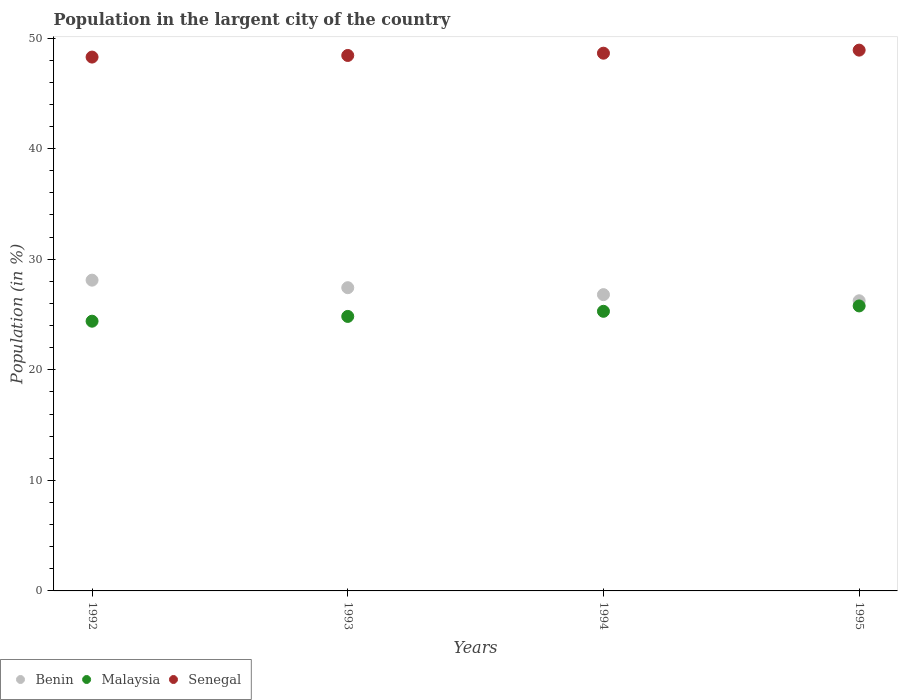How many different coloured dotlines are there?
Make the answer very short. 3. Is the number of dotlines equal to the number of legend labels?
Offer a very short reply. Yes. What is the percentage of population in the largent city in Malaysia in 1993?
Ensure brevity in your answer.  24.83. Across all years, what is the maximum percentage of population in the largent city in Malaysia?
Your answer should be compact. 25.78. Across all years, what is the minimum percentage of population in the largent city in Malaysia?
Keep it short and to the point. 24.39. What is the total percentage of population in the largent city in Benin in the graph?
Keep it short and to the point. 108.57. What is the difference between the percentage of population in the largent city in Malaysia in 1992 and that in 1995?
Give a very brief answer. -1.38. What is the difference between the percentage of population in the largent city in Malaysia in 1994 and the percentage of population in the largent city in Senegal in 1992?
Your answer should be compact. -22.99. What is the average percentage of population in the largent city in Senegal per year?
Offer a terse response. 48.56. In the year 1993, what is the difference between the percentage of population in the largent city in Senegal and percentage of population in the largent city in Malaysia?
Make the answer very short. 23.6. In how many years, is the percentage of population in the largent city in Malaysia greater than 48 %?
Offer a terse response. 0. What is the ratio of the percentage of population in the largent city in Malaysia in 1993 to that in 1994?
Offer a very short reply. 0.98. What is the difference between the highest and the second highest percentage of population in the largent city in Senegal?
Provide a succinct answer. 0.28. What is the difference between the highest and the lowest percentage of population in the largent city in Senegal?
Provide a short and direct response. 0.63. In how many years, is the percentage of population in the largent city in Malaysia greater than the average percentage of population in the largent city in Malaysia taken over all years?
Offer a terse response. 2. Is the sum of the percentage of population in the largent city in Malaysia in 1992 and 1994 greater than the maximum percentage of population in the largent city in Senegal across all years?
Ensure brevity in your answer.  Yes. Is it the case that in every year, the sum of the percentage of population in the largent city in Benin and percentage of population in the largent city in Malaysia  is greater than the percentage of population in the largent city in Senegal?
Ensure brevity in your answer.  Yes. Does the percentage of population in the largent city in Benin monotonically increase over the years?
Ensure brevity in your answer.  No. How many years are there in the graph?
Your answer should be very brief. 4. How many legend labels are there?
Ensure brevity in your answer.  3. How are the legend labels stacked?
Your response must be concise. Horizontal. What is the title of the graph?
Your response must be concise. Population in the largent city of the country. Does "Low & middle income" appear as one of the legend labels in the graph?
Your response must be concise. No. What is the Population (in %) in Benin in 1992?
Offer a terse response. 28.11. What is the Population (in %) of Malaysia in 1992?
Keep it short and to the point. 24.39. What is the Population (in %) in Senegal in 1992?
Your response must be concise. 48.28. What is the Population (in %) in Benin in 1993?
Provide a succinct answer. 27.43. What is the Population (in %) in Malaysia in 1993?
Offer a very short reply. 24.83. What is the Population (in %) in Senegal in 1993?
Your answer should be very brief. 48.43. What is the Population (in %) of Benin in 1994?
Provide a succinct answer. 26.8. What is the Population (in %) of Malaysia in 1994?
Ensure brevity in your answer.  25.29. What is the Population (in %) of Senegal in 1994?
Your answer should be very brief. 48.63. What is the Population (in %) in Benin in 1995?
Offer a very short reply. 26.24. What is the Population (in %) of Malaysia in 1995?
Give a very brief answer. 25.78. What is the Population (in %) in Senegal in 1995?
Your response must be concise. 48.91. Across all years, what is the maximum Population (in %) of Benin?
Provide a short and direct response. 28.11. Across all years, what is the maximum Population (in %) of Malaysia?
Provide a succinct answer. 25.78. Across all years, what is the maximum Population (in %) of Senegal?
Keep it short and to the point. 48.91. Across all years, what is the minimum Population (in %) in Benin?
Make the answer very short. 26.24. Across all years, what is the minimum Population (in %) of Malaysia?
Give a very brief answer. 24.39. Across all years, what is the minimum Population (in %) in Senegal?
Give a very brief answer. 48.28. What is the total Population (in %) of Benin in the graph?
Ensure brevity in your answer.  108.57. What is the total Population (in %) of Malaysia in the graph?
Your answer should be compact. 100.29. What is the total Population (in %) in Senegal in the graph?
Your answer should be very brief. 194.26. What is the difference between the Population (in %) in Benin in 1992 and that in 1993?
Your answer should be very brief. 0.68. What is the difference between the Population (in %) in Malaysia in 1992 and that in 1993?
Give a very brief answer. -0.43. What is the difference between the Population (in %) of Senegal in 1992 and that in 1993?
Ensure brevity in your answer.  -0.15. What is the difference between the Population (in %) of Benin in 1992 and that in 1994?
Keep it short and to the point. 1.31. What is the difference between the Population (in %) of Malaysia in 1992 and that in 1994?
Offer a very short reply. -0.89. What is the difference between the Population (in %) in Senegal in 1992 and that in 1994?
Provide a succinct answer. -0.35. What is the difference between the Population (in %) of Benin in 1992 and that in 1995?
Keep it short and to the point. 1.86. What is the difference between the Population (in %) of Malaysia in 1992 and that in 1995?
Ensure brevity in your answer.  -1.38. What is the difference between the Population (in %) in Senegal in 1992 and that in 1995?
Provide a short and direct response. -0.63. What is the difference between the Population (in %) in Benin in 1993 and that in 1994?
Your answer should be compact. 0.63. What is the difference between the Population (in %) of Malaysia in 1993 and that in 1994?
Provide a succinct answer. -0.46. What is the difference between the Population (in %) of Senegal in 1993 and that in 1994?
Offer a terse response. -0.21. What is the difference between the Population (in %) of Benin in 1993 and that in 1995?
Offer a very short reply. 1.18. What is the difference between the Population (in %) in Malaysia in 1993 and that in 1995?
Your answer should be compact. -0.95. What is the difference between the Population (in %) of Senegal in 1993 and that in 1995?
Your answer should be compact. -0.48. What is the difference between the Population (in %) of Benin in 1994 and that in 1995?
Give a very brief answer. 0.56. What is the difference between the Population (in %) in Malaysia in 1994 and that in 1995?
Your answer should be compact. -0.49. What is the difference between the Population (in %) of Senegal in 1994 and that in 1995?
Your answer should be very brief. -0.28. What is the difference between the Population (in %) in Benin in 1992 and the Population (in %) in Malaysia in 1993?
Give a very brief answer. 3.28. What is the difference between the Population (in %) in Benin in 1992 and the Population (in %) in Senegal in 1993?
Keep it short and to the point. -20.32. What is the difference between the Population (in %) of Malaysia in 1992 and the Population (in %) of Senegal in 1993?
Your response must be concise. -24.03. What is the difference between the Population (in %) of Benin in 1992 and the Population (in %) of Malaysia in 1994?
Your answer should be compact. 2.82. What is the difference between the Population (in %) of Benin in 1992 and the Population (in %) of Senegal in 1994?
Offer a terse response. -20.53. What is the difference between the Population (in %) in Malaysia in 1992 and the Population (in %) in Senegal in 1994?
Make the answer very short. -24.24. What is the difference between the Population (in %) in Benin in 1992 and the Population (in %) in Malaysia in 1995?
Provide a succinct answer. 2.33. What is the difference between the Population (in %) in Benin in 1992 and the Population (in %) in Senegal in 1995?
Your response must be concise. -20.8. What is the difference between the Population (in %) of Malaysia in 1992 and the Population (in %) of Senegal in 1995?
Provide a succinct answer. -24.52. What is the difference between the Population (in %) in Benin in 1993 and the Population (in %) in Malaysia in 1994?
Offer a terse response. 2.14. What is the difference between the Population (in %) of Benin in 1993 and the Population (in %) of Senegal in 1994?
Make the answer very short. -21.21. What is the difference between the Population (in %) of Malaysia in 1993 and the Population (in %) of Senegal in 1994?
Offer a very short reply. -23.81. What is the difference between the Population (in %) in Benin in 1993 and the Population (in %) in Malaysia in 1995?
Offer a very short reply. 1.65. What is the difference between the Population (in %) of Benin in 1993 and the Population (in %) of Senegal in 1995?
Make the answer very short. -21.49. What is the difference between the Population (in %) of Malaysia in 1993 and the Population (in %) of Senegal in 1995?
Ensure brevity in your answer.  -24.08. What is the difference between the Population (in %) of Benin in 1994 and the Population (in %) of Malaysia in 1995?
Your response must be concise. 1.02. What is the difference between the Population (in %) of Benin in 1994 and the Population (in %) of Senegal in 1995?
Offer a very short reply. -22.11. What is the difference between the Population (in %) in Malaysia in 1994 and the Population (in %) in Senegal in 1995?
Offer a very short reply. -23.62. What is the average Population (in %) of Benin per year?
Your answer should be compact. 27.14. What is the average Population (in %) in Malaysia per year?
Ensure brevity in your answer.  25.07. What is the average Population (in %) in Senegal per year?
Give a very brief answer. 48.56. In the year 1992, what is the difference between the Population (in %) in Benin and Population (in %) in Malaysia?
Give a very brief answer. 3.71. In the year 1992, what is the difference between the Population (in %) of Benin and Population (in %) of Senegal?
Make the answer very short. -20.18. In the year 1992, what is the difference between the Population (in %) of Malaysia and Population (in %) of Senegal?
Ensure brevity in your answer.  -23.89. In the year 1993, what is the difference between the Population (in %) of Benin and Population (in %) of Malaysia?
Make the answer very short. 2.6. In the year 1993, what is the difference between the Population (in %) in Benin and Population (in %) in Senegal?
Keep it short and to the point. -21. In the year 1993, what is the difference between the Population (in %) of Malaysia and Population (in %) of Senegal?
Keep it short and to the point. -23.6. In the year 1994, what is the difference between the Population (in %) in Benin and Population (in %) in Malaysia?
Give a very brief answer. 1.51. In the year 1994, what is the difference between the Population (in %) in Benin and Population (in %) in Senegal?
Provide a short and direct response. -21.84. In the year 1994, what is the difference between the Population (in %) in Malaysia and Population (in %) in Senegal?
Provide a succinct answer. -23.35. In the year 1995, what is the difference between the Population (in %) of Benin and Population (in %) of Malaysia?
Your response must be concise. 0.47. In the year 1995, what is the difference between the Population (in %) of Benin and Population (in %) of Senegal?
Provide a short and direct response. -22.67. In the year 1995, what is the difference between the Population (in %) of Malaysia and Population (in %) of Senegal?
Your answer should be compact. -23.14. What is the ratio of the Population (in %) in Benin in 1992 to that in 1993?
Your answer should be compact. 1.02. What is the ratio of the Population (in %) in Malaysia in 1992 to that in 1993?
Provide a short and direct response. 0.98. What is the ratio of the Population (in %) of Benin in 1992 to that in 1994?
Your answer should be compact. 1.05. What is the ratio of the Population (in %) in Malaysia in 1992 to that in 1994?
Offer a terse response. 0.96. What is the ratio of the Population (in %) in Senegal in 1992 to that in 1994?
Offer a very short reply. 0.99. What is the ratio of the Population (in %) of Benin in 1992 to that in 1995?
Ensure brevity in your answer.  1.07. What is the ratio of the Population (in %) of Malaysia in 1992 to that in 1995?
Provide a short and direct response. 0.95. What is the ratio of the Population (in %) in Senegal in 1992 to that in 1995?
Your answer should be compact. 0.99. What is the ratio of the Population (in %) in Benin in 1993 to that in 1994?
Your response must be concise. 1.02. What is the ratio of the Population (in %) in Malaysia in 1993 to that in 1994?
Provide a short and direct response. 0.98. What is the ratio of the Population (in %) in Senegal in 1993 to that in 1994?
Offer a terse response. 1. What is the ratio of the Population (in %) in Benin in 1993 to that in 1995?
Offer a very short reply. 1.05. What is the ratio of the Population (in %) of Malaysia in 1993 to that in 1995?
Keep it short and to the point. 0.96. What is the ratio of the Population (in %) of Benin in 1994 to that in 1995?
Provide a short and direct response. 1.02. What is the ratio of the Population (in %) of Malaysia in 1994 to that in 1995?
Keep it short and to the point. 0.98. What is the ratio of the Population (in %) of Senegal in 1994 to that in 1995?
Provide a succinct answer. 0.99. What is the difference between the highest and the second highest Population (in %) in Benin?
Provide a succinct answer. 0.68. What is the difference between the highest and the second highest Population (in %) of Malaysia?
Keep it short and to the point. 0.49. What is the difference between the highest and the second highest Population (in %) of Senegal?
Provide a succinct answer. 0.28. What is the difference between the highest and the lowest Population (in %) of Benin?
Offer a very short reply. 1.86. What is the difference between the highest and the lowest Population (in %) of Malaysia?
Give a very brief answer. 1.38. What is the difference between the highest and the lowest Population (in %) of Senegal?
Provide a short and direct response. 0.63. 